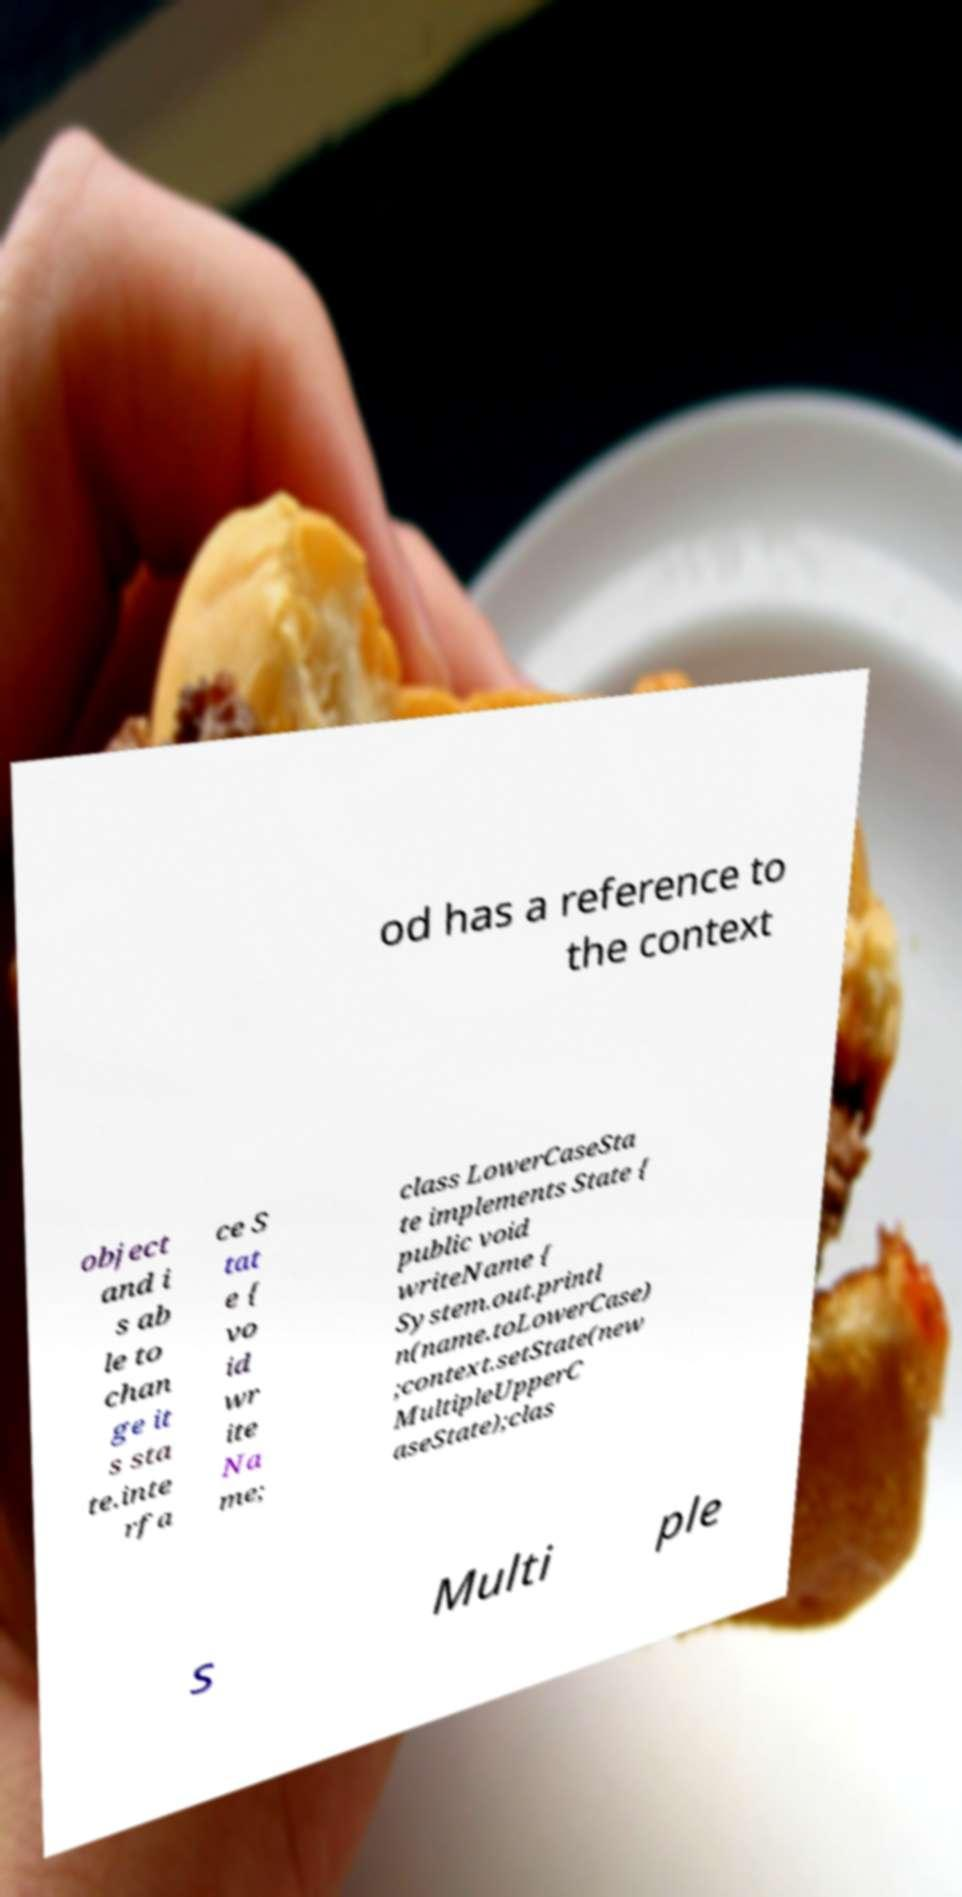Can you read and provide the text displayed in the image?This photo seems to have some interesting text. Can you extract and type it out for me? od has a reference to the context object and i s ab le to chan ge it s sta te.inte rfa ce S tat e { vo id wr ite Na me; class LowerCaseSta te implements State { public void writeName { System.out.printl n(name.toLowerCase) ;context.setState(new MultipleUpperC aseState);clas s Multi ple 